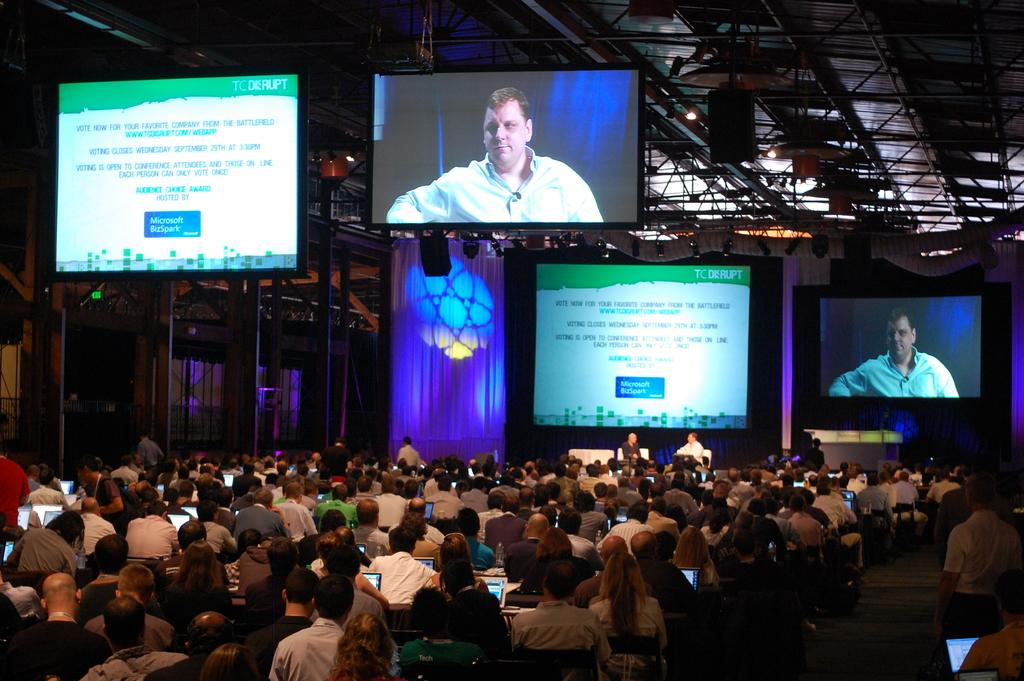<image>
Summarize the visual content of the image. An event with screens that read VOTE NOW FOR YOUR FAVORITE COMPANY FROM THE BATTLEFIELD 